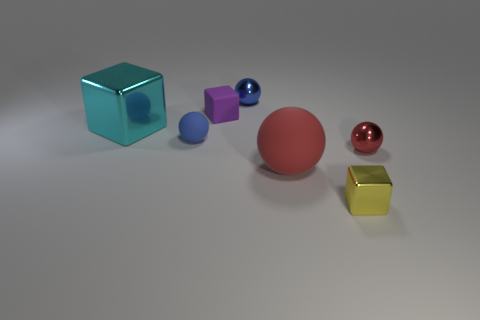Are the objects arranged in a specific pattern or order? The objects appear to be arranged based on their shapes and sizes, incrementally increasing in size towards the red sphere, which is the largest object. What might be the significance of the different colors used? The varied colors could be used to differentiate the shapes or simply for aesthetic purposes, enhancing the visual appeal by providing contrast among the objects. 